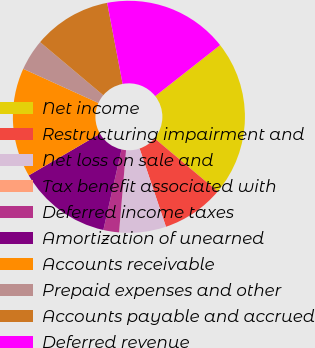Convert chart. <chart><loc_0><loc_0><loc_500><loc_500><pie_chart><fcel>Net income<fcel>Restructuring impairment and<fcel>Net loss on sale and<fcel>Tax benefit associated with<fcel>Deferred income taxes<fcel>Amortization of unearned<fcel>Accounts receivable<fcel>Prepaid expenses and other<fcel>Accounts payable and accrued<fcel>Deferred revenue<nl><fcel>21.73%<fcel>8.7%<fcel>6.52%<fcel>0.01%<fcel>2.18%<fcel>13.04%<fcel>15.21%<fcel>4.35%<fcel>10.87%<fcel>17.39%<nl></chart> 